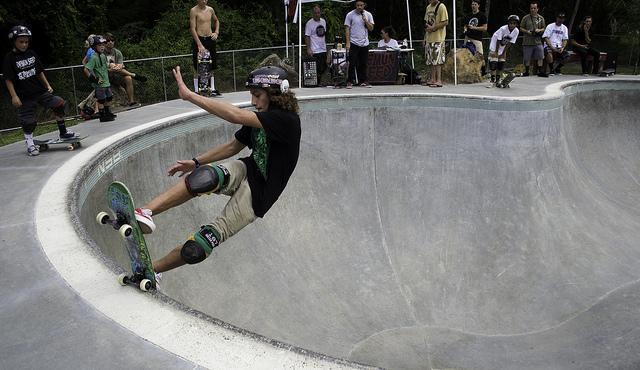How many skateboards can be seen?
Give a very brief answer. 1. How many people can you see?
Give a very brief answer. 3. How many kites are flying in the sky?
Give a very brief answer. 0. 